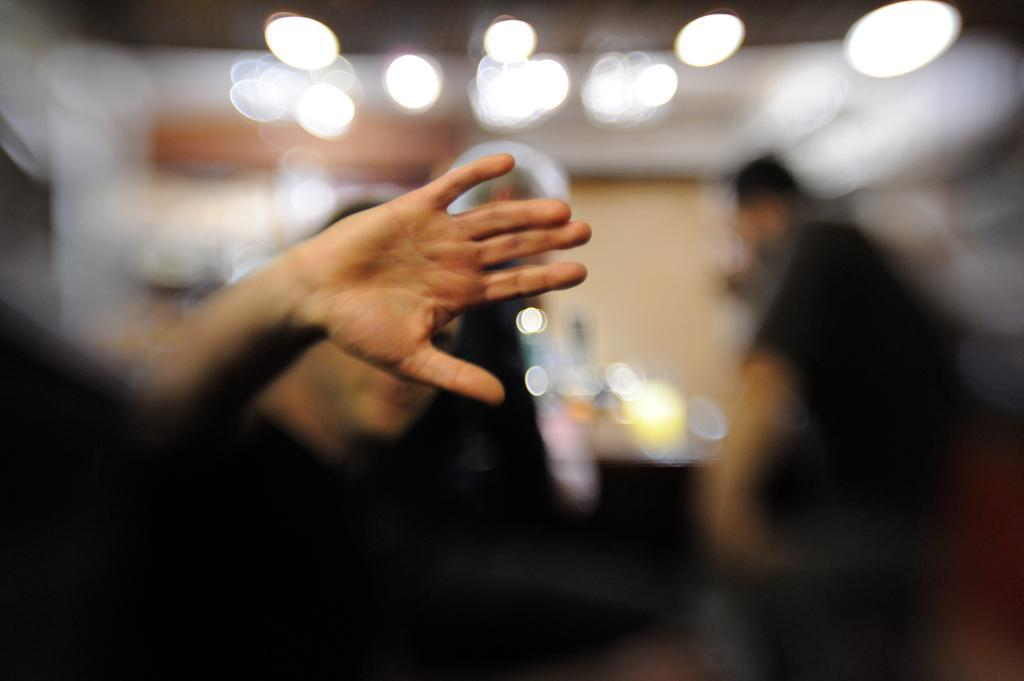What is the main subject of the image? The main subject of the image is a person's hand. Can you describe the background of the image? The background of the image is blurred. What type of order is being placed at the square table in the image? There is no table, square or otherwise, and no order being placed in the image; it only features a person's hand. 